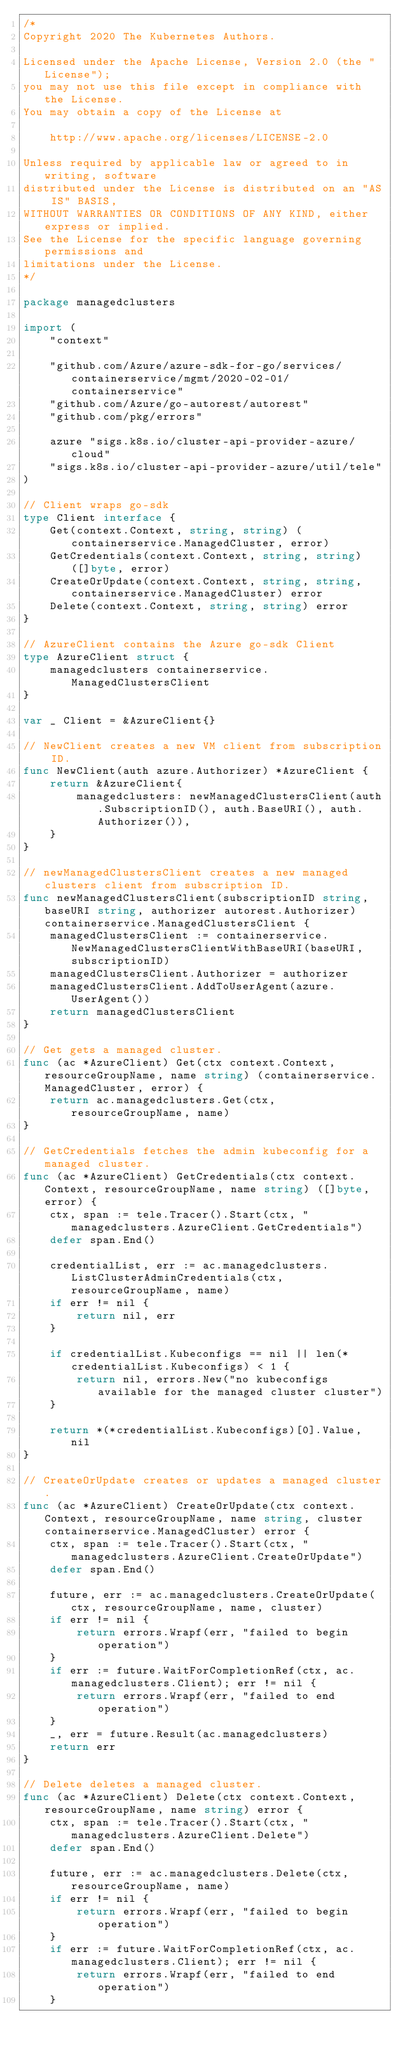Convert code to text. <code><loc_0><loc_0><loc_500><loc_500><_Go_>/*
Copyright 2020 The Kubernetes Authors.

Licensed under the Apache License, Version 2.0 (the "License");
you may not use this file except in compliance with the License.
You may obtain a copy of the License at

    http://www.apache.org/licenses/LICENSE-2.0

Unless required by applicable law or agreed to in writing, software
distributed under the License is distributed on an "AS IS" BASIS,
WITHOUT WARRANTIES OR CONDITIONS OF ANY KIND, either express or implied.
See the License for the specific language governing permissions and
limitations under the License.
*/

package managedclusters

import (
	"context"

	"github.com/Azure/azure-sdk-for-go/services/containerservice/mgmt/2020-02-01/containerservice"
	"github.com/Azure/go-autorest/autorest"
	"github.com/pkg/errors"

	azure "sigs.k8s.io/cluster-api-provider-azure/cloud"
	"sigs.k8s.io/cluster-api-provider-azure/util/tele"
)

// Client wraps go-sdk
type Client interface {
	Get(context.Context, string, string) (containerservice.ManagedCluster, error)
	GetCredentials(context.Context, string, string) ([]byte, error)
	CreateOrUpdate(context.Context, string, string, containerservice.ManagedCluster) error
	Delete(context.Context, string, string) error
}

// AzureClient contains the Azure go-sdk Client
type AzureClient struct {
	managedclusters containerservice.ManagedClustersClient
}

var _ Client = &AzureClient{}

// NewClient creates a new VM client from subscription ID.
func NewClient(auth azure.Authorizer) *AzureClient {
	return &AzureClient{
		managedclusters: newManagedClustersClient(auth.SubscriptionID(), auth.BaseURI(), auth.Authorizer()),
	}
}

// newManagedClustersClient creates a new managed clusters client from subscription ID.
func newManagedClustersClient(subscriptionID string, baseURI string, authorizer autorest.Authorizer) containerservice.ManagedClustersClient {
	managedClustersClient := containerservice.NewManagedClustersClientWithBaseURI(baseURI, subscriptionID)
	managedClustersClient.Authorizer = authorizer
	managedClustersClient.AddToUserAgent(azure.UserAgent())
	return managedClustersClient
}

// Get gets a managed cluster.
func (ac *AzureClient) Get(ctx context.Context, resourceGroupName, name string) (containerservice.ManagedCluster, error) {
	return ac.managedclusters.Get(ctx, resourceGroupName, name)
}

// GetCredentials fetches the admin kubeconfig for a managed cluster.
func (ac *AzureClient) GetCredentials(ctx context.Context, resourceGroupName, name string) ([]byte, error) {
	ctx, span := tele.Tracer().Start(ctx, "managedclusters.AzureClient.GetCredentials")
	defer span.End()

	credentialList, err := ac.managedclusters.ListClusterAdminCredentials(ctx, resourceGroupName, name)
	if err != nil {
		return nil, err
	}

	if credentialList.Kubeconfigs == nil || len(*credentialList.Kubeconfigs) < 1 {
		return nil, errors.New("no kubeconfigs available for the managed cluster cluster")
	}

	return *(*credentialList.Kubeconfigs)[0].Value, nil
}

// CreateOrUpdate creates or updates a managed cluster.
func (ac *AzureClient) CreateOrUpdate(ctx context.Context, resourceGroupName, name string, cluster containerservice.ManagedCluster) error {
	ctx, span := tele.Tracer().Start(ctx, "managedclusters.AzureClient.CreateOrUpdate")
	defer span.End()

	future, err := ac.managedclusters.CreateOrUpdate(ctx, resourceGroupName, name, cluster)
	if err != nil {
		return errors.Wrapf(err, "failed to begin operation")
	}
	if err := future.WaitForCompletionRef(ctx, ac.managedclusters.Client); err != nil {
		return errors.Wrapf(err, "failed to end operation")
	}
	_, err = future.Result(ac.managedclusters)
	return err
}

// Delete deletes a managed cluster.
func (ac *AzureClient) Delete(ctx context.Context, resourceGroupName, name string) error {
	ctx, span := tele.Tracer().Start(ctx, "managedclusters.AzureClient.Delete")
	defer span.End()

	future, err := ac.managedclusters.Delete(ctx, resourceGroupName, name)
	if err != nil {
		return errors.Wrapf(err, "failed to begin operation")
	}
	if err := future.WaitForCompletionRef(ctx, ac.managedclusters.Client); err != nil {
		return errors.Wrapf(err, "failed to end operation")
	}</code> 